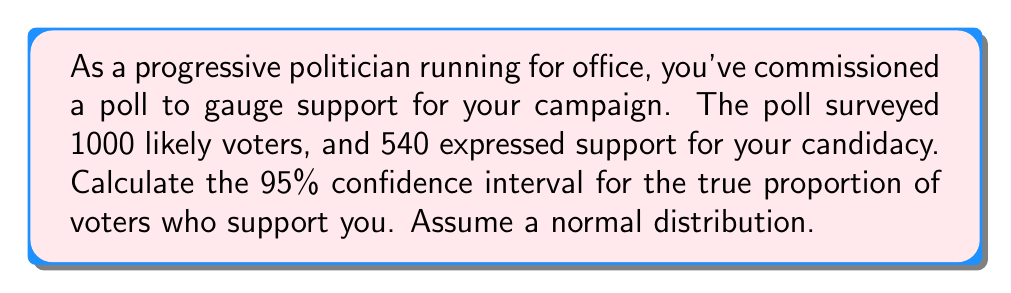Teach me how to tackle this problem. To calculate the 95% confidence interval, we'll follow these steps:

1. Calculate the sample proportion:
   $\hat{p} = \frac{540}{1000} = 0.54$

2. Calculate the standard error:
   $SE = \sqrt{\frac{\hat{p}(1-\hat{p})}{n}} = \sqrt{\frac{0.54(1-0.54)}{1000}} = 0.0157$

3. Find the z-score for a 95% confidence interval:
   For a 95% CI, z = 1.96

4. Calculate the margin of error:
   $ME = z \times SE = 1.96 \times 0.0157 = 0.0308$

5. Calculate the confidence interval:
   $CI = \hat{p} \pm ME$
   Lower bound: $0.54 - 0.0308 = 0.5092$
   Upper bound: $0.54 + 0.0308 = 0.5708$

Therefore, the 95% confidence interval is (0.5092, 0.5708) or (50.92%, 57.08%).

This means we can be 95% confident that the true proportion of voters who support your candidacy falls between 50.92% and 57.08%.
Answer: (0.5092, 0.5708) or (50.92%, 57.08%) 